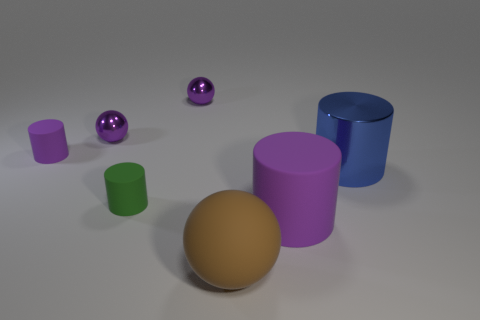Subtract all purple metallic spheres. How many spheres are left? 1 Add 1 rubber spheres. How many objects exist? 8 Subtract 1 spheres. How many spheres are left? 2 Subtract all green cylinders. How many cylinders are left? 3 Subtract all spheres. How many objects are left? 4 Subtract 0 purple cubes. How many objects are left? 7 Subtract all brown cylinders. Subtract all gray balls. How many cylinders are left? 4 Subtract all tiny green rubber objects. Subtract all tiny purple shiny objects. How many objects are left? 4 Add 3 cylinders. How many cylinders are left? 7 Add 5 large objects. How many large objects exist? 8 